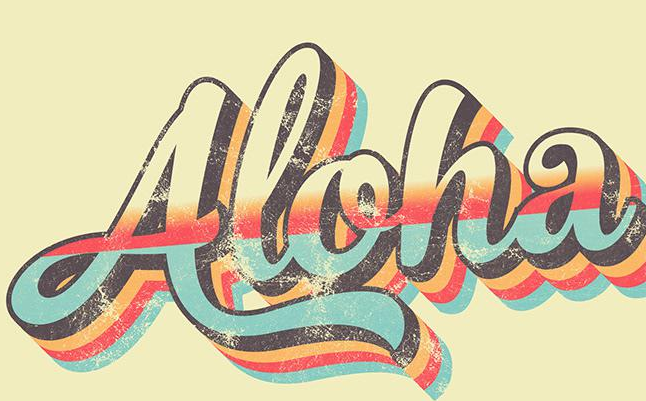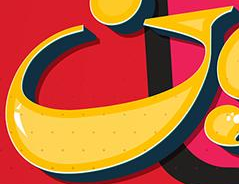What words are shown in these images in order, separated by a semicolon? Aloha; G 